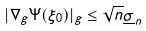<formula> <loc_0><loc_0><loc_500><loc_500>| \nabla _ { g } \Psi ( \xi _ { 0 } ) | _ { g } \leq \sqrt { n } \underline { \sigma } _ { n }</formula> 